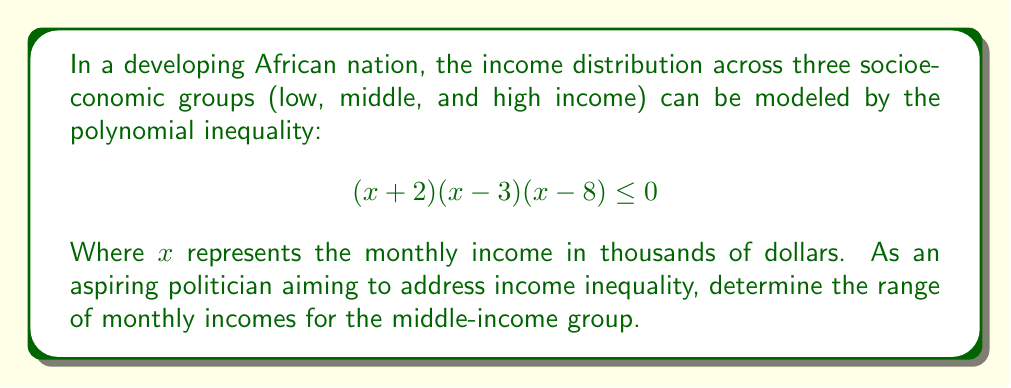Show me your answer to this math problem. To solve this polynomial inequality, we need to follow these steps:

1) First, let's identify the roots of the polynomial:
   $x = -2$, $x = 3$, and $x = 8$

2) These roots divide the real number line into four regions. We need to determine where the polynomial is non-positive (less than or equal to zero).

3) Let's test each region by choosing a point in that region and evaluating the sign of the polynomial:

   For $x < -2$: Choose $x = -3$
   $(-3+2)(-3-3)(-3-8) = (-1)(-6)(-11) > 0$

   For $-2 < x < 3$: Choose $x = 0$
   $(0+2)(0-3)(0-8) = (2)(-3)(-8) > 0$

   For $3 < x < 8$: Choose $x = 5$
   $(5+2)(5-3)(5-8) = (7)(2)(-3) < 0$

   For $x > 8$: Choose $x = 9$
   $(9+2)(9-3)(9-8) = (11)(6)(1) > 0$

4) The inequality is satisfied when $3 \leq x \leq 8$

5) Interpreting this in the context of the problem:
   The middle-income group has monthly incomes ranging from $3,000 to $8,000.
Answer: $3 \leq x \leq 8$, or $[3000, 8000]$ in dollars 